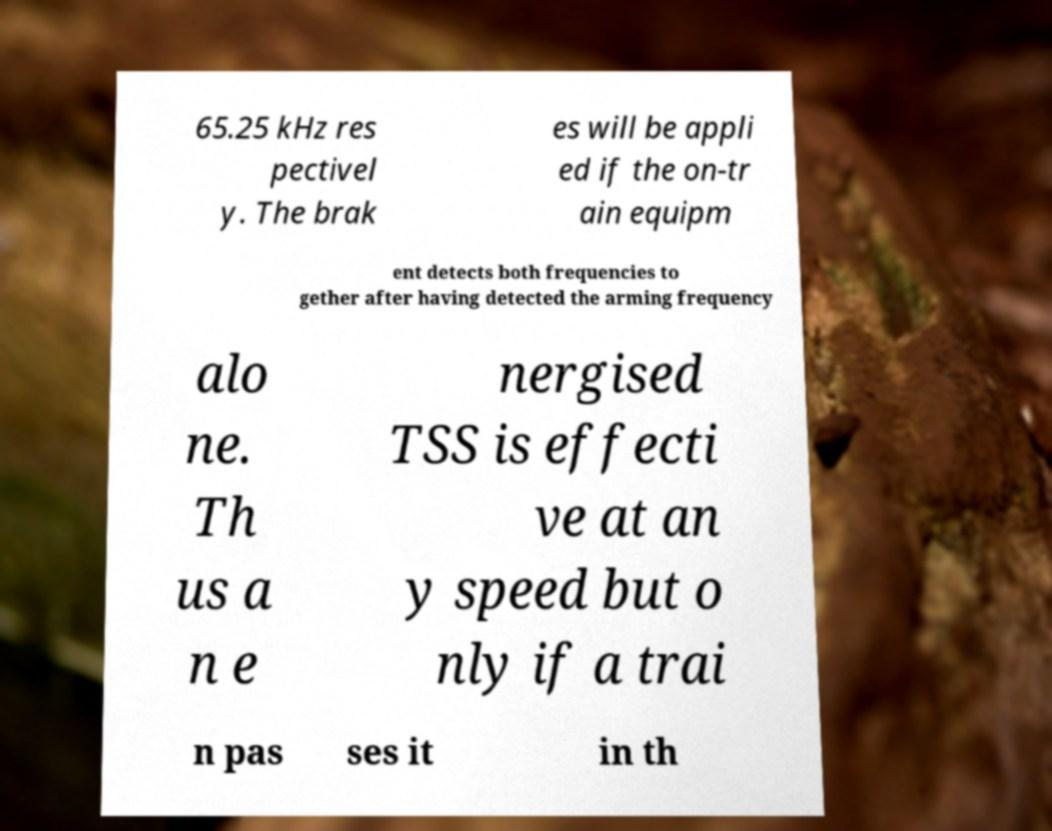Could you extract and type out the text from this image? 65.25 kHz res pectivel y. The brak es will be appli ed if the on-tr ain equipm ent detects both frequencies to gether after having detected the arming frequency alo ne. Th us a n e nergised TSS is effecti ve at an y speed but o nly if a trai n pas ses it in th 